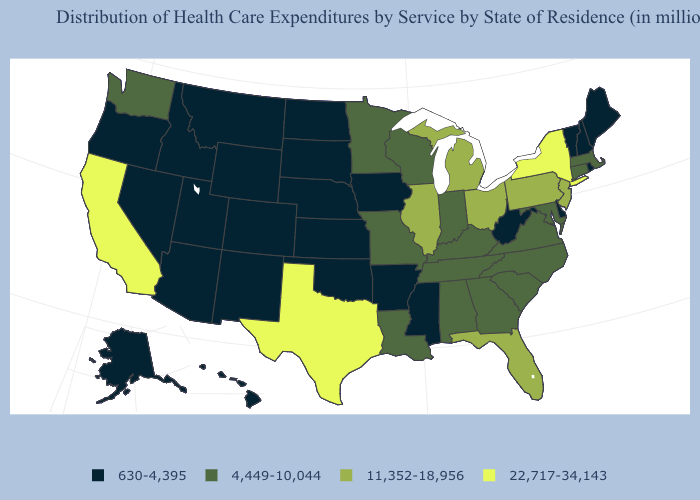Name the states that have a value in the range 4,449-10,044?
Concise answer only. Alabama, Connecticut, Georgia, Indiana, Kentucky, Louisiana, Maryland, Massachusetts, Minnesota, Missouri, North Carolina, South Carolina, Tennessee, Virginia, Washington, Wisconsin. What is the highest value in the USA?
Answer briefly. 22,717-34,143. Which states have the lowest value in the West?
Short answer required. Alaska, Arizona, Colorado, Hawaii, Idaho, Montana, Nevada, New Mexico, Oregon, Utah, Wyoming. Which states hav the highest value in the MidWest?
Quick response, please. Illinois, Michigan, Ohio. Which states have the lowest value in the West?
Keep it brief. Alaska, Arizona, Colorado, Hawaii, Idaho, Montana, Nevada, New Mexico, Oregon, Utah, Wyoming. What is the value of Hawaii?
Be succinct. 630-4,395. Does Oregon have the highest value in the West?
Be succinct. No. Among the states that border Mississippi , does Tennessee have the highest value?
Be succinct. Yes. Does the map have missing data?
Write a very short answer. No. What is the value of Oregon?
Write a very short answer. 630-4,395. How many symbols are there in the legend?
Write a very short answer. 4. What is the value of New Hampshire?
Quick response, please. 630-4,395. Name the states that have a value in the range 11,352-18,956?
Quick response, please. Florida, Illinois, Michigan, New Jersey, Ohio, Pennsylvania. Name the states that have a value in the range 22,717-34,143?
Be succinct. California, New York, Texas. 